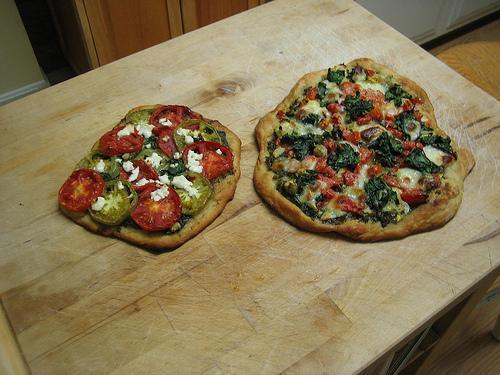How many pizzas are there?
Give a very brief answer. 2. How many pizza's are there?
Give a very brief answer. 2. How many pizzas are shown?
Give a very brief answer. 2. 